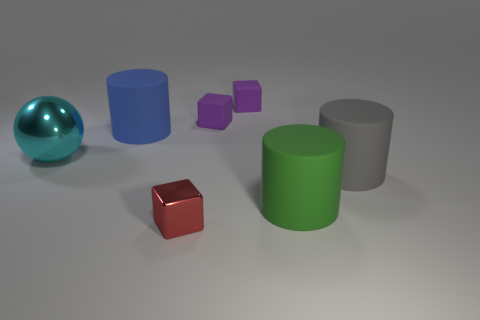What can you infer about the sizes of the objects relative to each other? From their appearance, the green cylinder is the largest object in terms of height and overall volume, followed by the gray cylinder which is slightly shorter. The blue cylinder appears to have a smaller diameter but retains the same height as the gray. The small purple cubes are identical in size to each other, and the brown and red cubes are similarly the smallest objects in terms of both height and volume. 